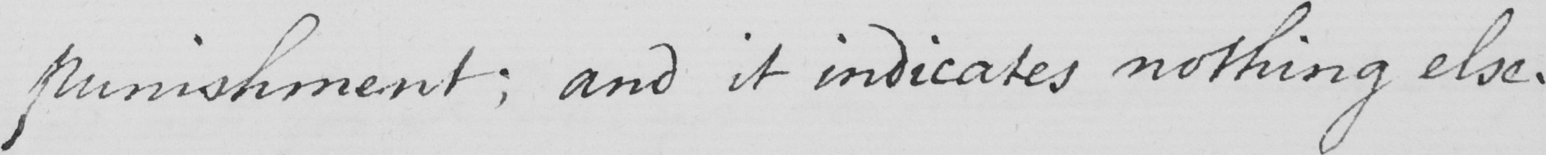Can you tell me what this handwritten text says? punishment ; and it indicates nothing else , 